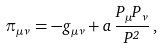<formula> <loc_0><loc_0><loc_500><loc_500>\pi _ { \mu \nu } = - g _ { \mu \nu } + a \, \frac { P _ { \mu } P _ { \nu } } { P ^ { 2 } } \, ,</formula> 